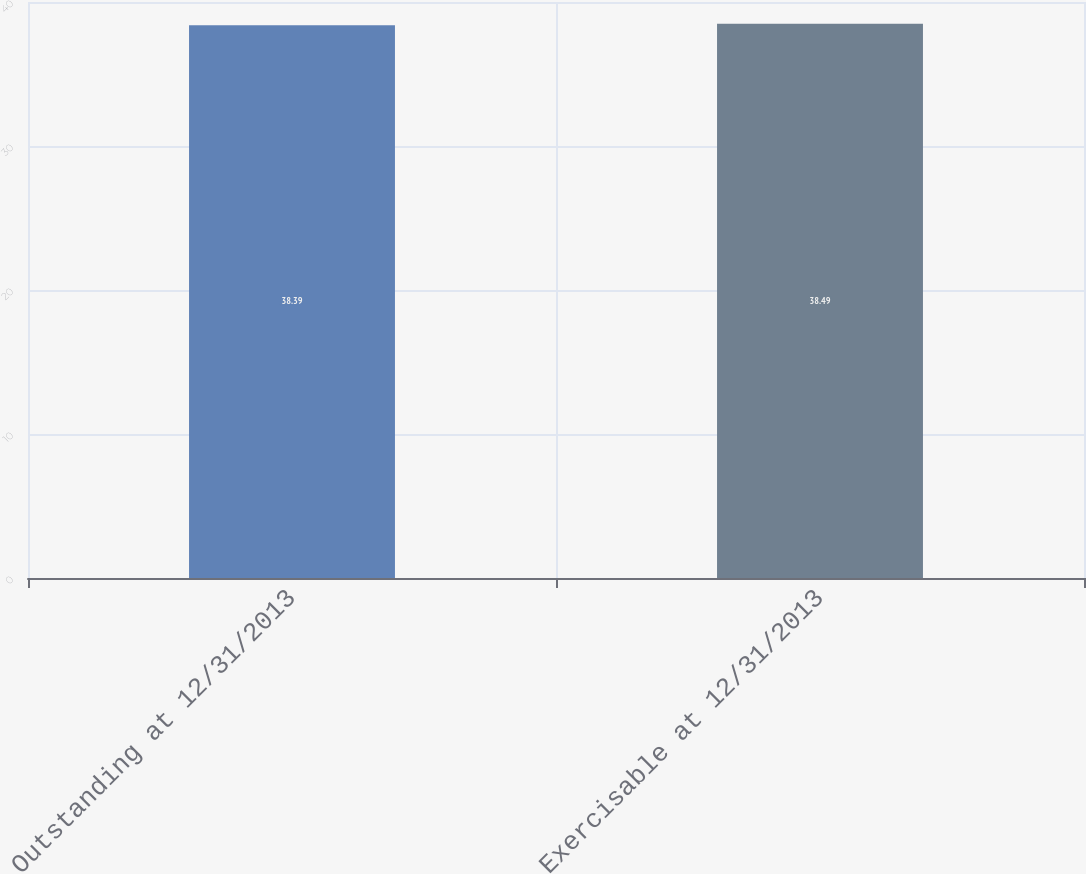Convert chart to OTSL. <chart><loc_0><loc_0><loc_500><loc_500><bar_chart><fcel>Outstanding at 12/31/2013<fcel>Exercisable at 12/31/2013<nl><fcel>38.39<fcel>38.49<nl></chart> 